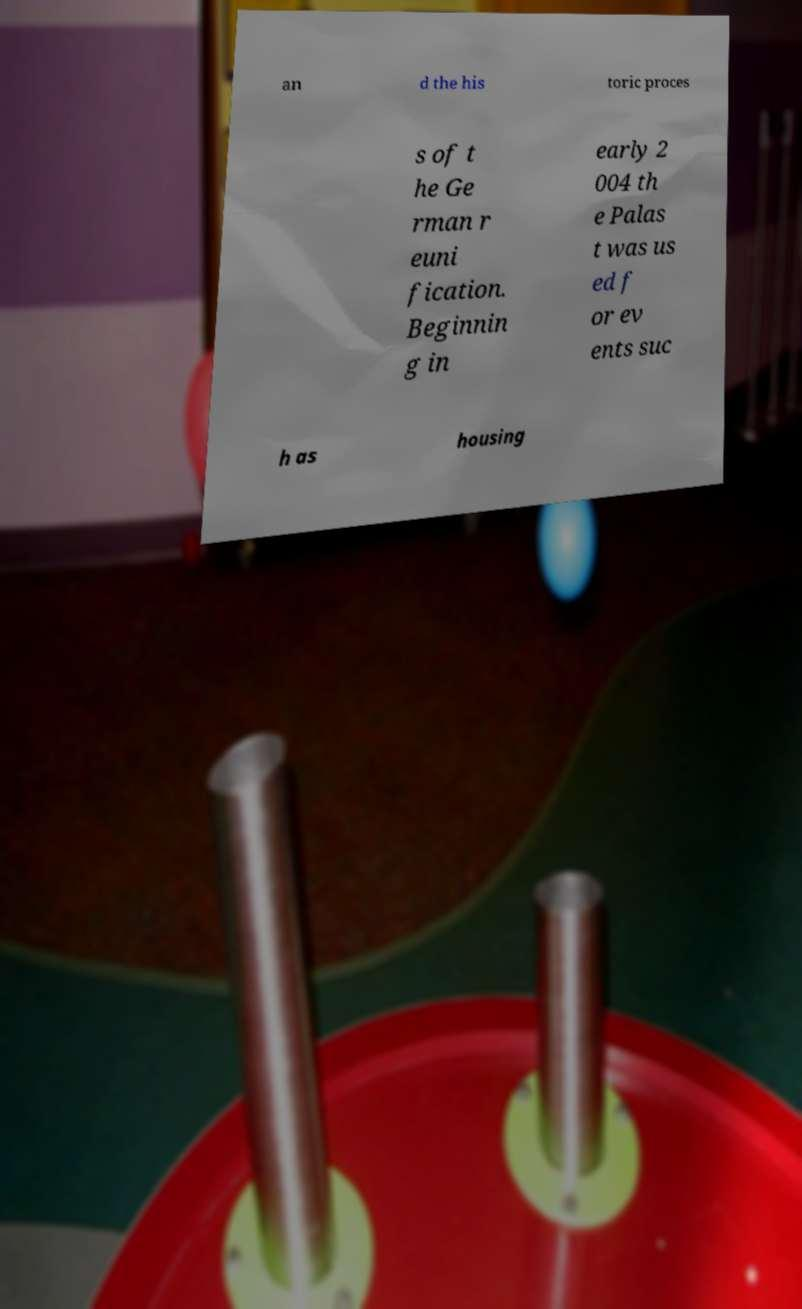I need the written content from this picture converted into text. Can you do that? an d the his toric proces s of t he Ge rman r euni fication. Beginnin g in early 2 004 th e Palas t was us ed f or ev ents suc h as housing 